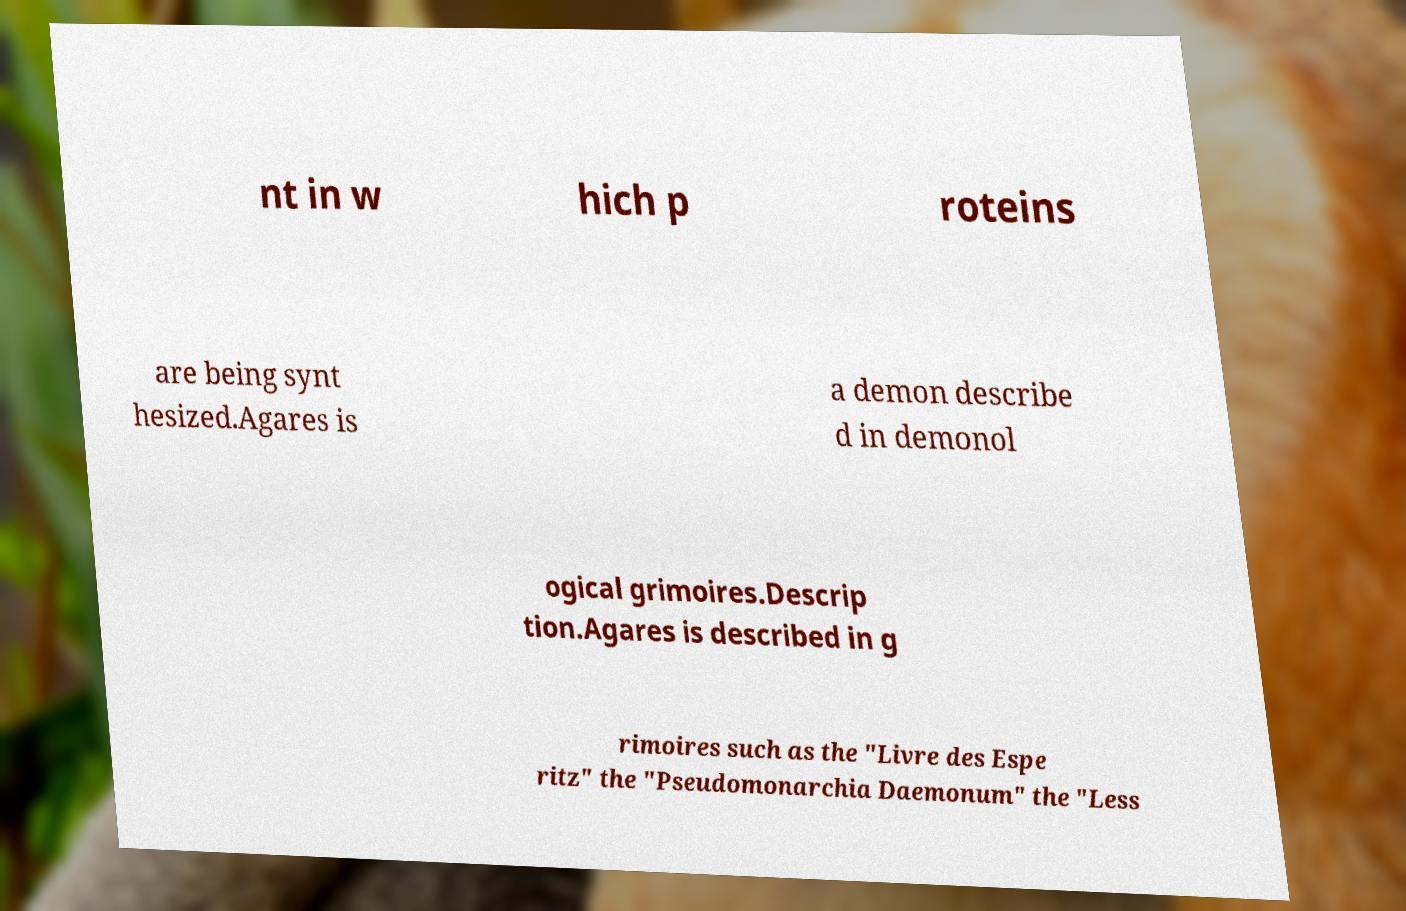There's text embedded in this image that I need extracted. Can you transcribe it verbatim? nt in w hich p roteins are being synt hesized.Agares is a demon describe d in demonol ogical grimoires.Descrip tion.Agares is described in g rimoires such as the "Livre des Espe ritz" the "Pseudomonarchia Daemonum" the "Less 